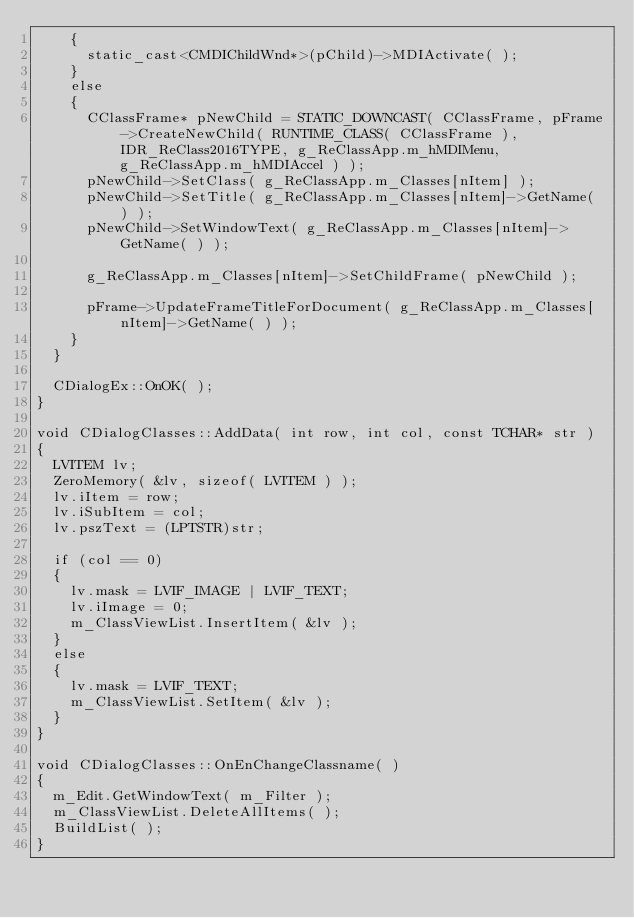Convert code to text. <code><loc_0><loc_0><loc_500><loc_500><_C++_>		{
			static_cast<CMDIChildWnd*>(pChild)->MDIActivate( );
		}
		else
		{
			CClassFrame* pNewChild = STATIC_DOWNCAST( CClassFrame, pFrame->CreateNewChild( RUNTIME_CLASS( CClassFrame ), IDR_ReClass2016TYPE, g_ReClassApp.m_hMDIMenu, g_ReClassApp.m_hMDIAccel ) );
			pNewChild->SetClass( g_ReClassApp.m_Classes[nItem] );
			pNewChild->SetTitle( g_ReClassApp.m_Classes[nItem]->GetName( ) );
			pNewChild->SetWindowText( g_ReClassApp.m_Classes[nItem]->GetName( ) );

			g_ReClassApp.m_Classes[nItem]->SetChildFrame( pNewChild );

			pFrame->UpdateFrameTitleForDocument( g_ReClassApp.m_Classes[nItem]->GetName( ) );
		}
	}

	CDialogEx::OnOK( );
}

void CDialogClasses::AddData( int row, int col, const TCHAR* str )
{
	LVITEM lv;
	ZeroMemory( &lv, sizeof( LVITEM ) );
	lv.iItem = row;
	lv.iSubItem = col;
	lv.pszText = (LPTSTR)str;

	if (col == 0)
	{
		lv.mask = LVIF_IMAGE | LVIF_TEXT;
		lv.iImage = 0;
		m_ClassViewList.InsertItem( &lv );
	}
	else
	{
		lv.mask = LVIF_TEXT;
		m_ClassViewList.SetItem( &lv );
	}
}

void CDialogClasses::OnEnChangeClassname( )
{
	m_Edit.GetWindowText( m_Filter );
	m_ClassViewList.DeleteAllItems( );
	BuildList( );
}
</code> 